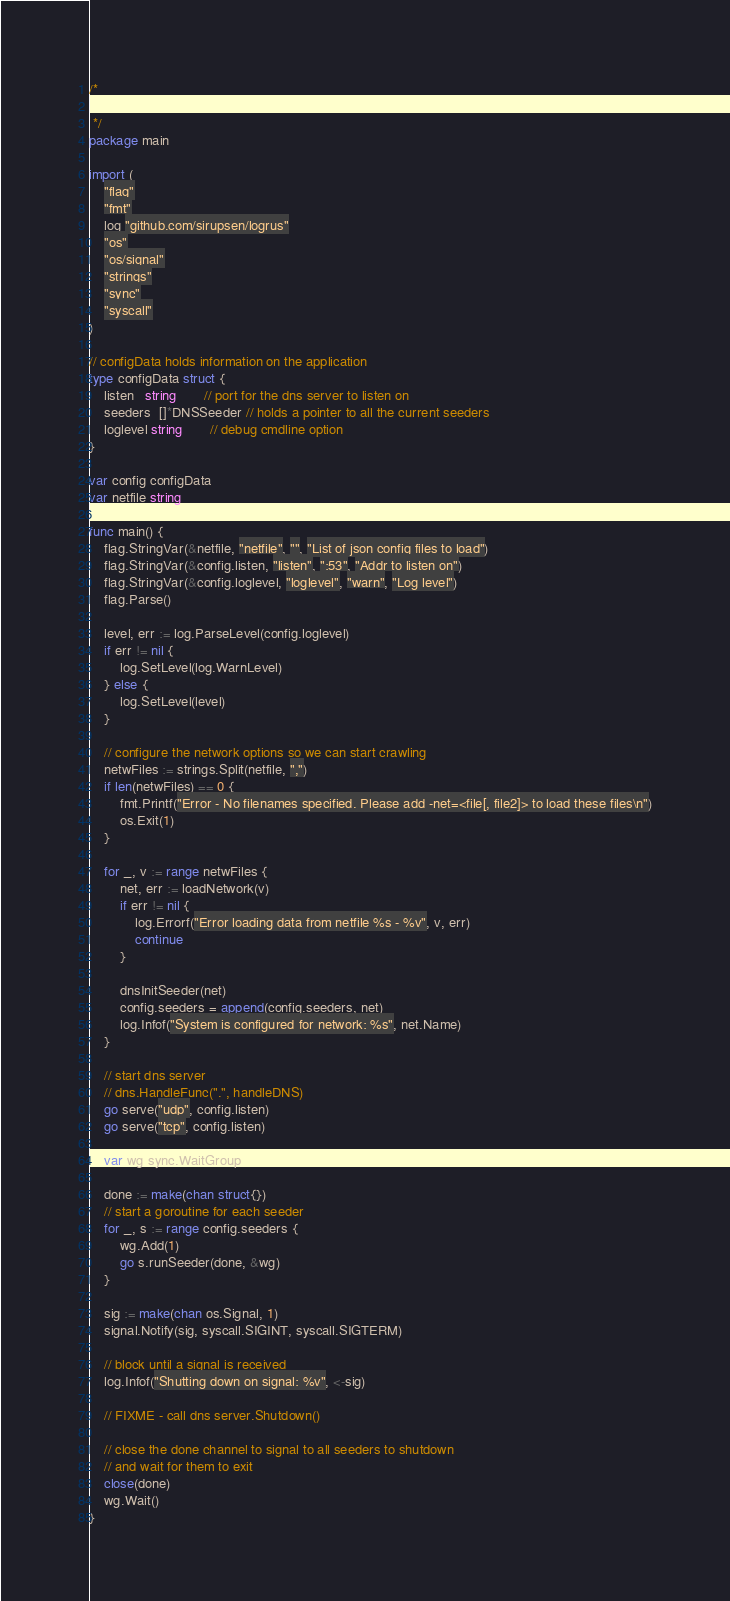Convert code to text. <code><loc_0><loc_0><loc_500><loc_500><_Go_>/*

 */
package main

import (
	"flag"
	"fmt"
	log "github.com/sirupsen/logrus"
	"os"
	"os/signal"
	"strings"
	"sync"
	"syscall"
)

// configData holds information on the application
type configData struct {
	listen   string       // port for the dns server to listen on
	seeders  []*DNSSeeder // holds a pointer to all the current seeders
	loglevel string       // debug cmdline option
}

var config configData
var netfile string

func main() {
	flag.StringVar(&netfile, "netfile", "", "List of json config files to load")
	flag.StringVar(&config.listen, "listen", ":53", "Addr to listen on")
	flag.StringVar(&config.loglevel, "loglevel", "warn", "Log level")
	flag.Parse()

	level, err := log.ParseLevel(config.loglevel)
	if err != nil {
		log.SetLevel(log.WarnLevel)
	} else {
		log.SetLevel(level)
	}

	// configure the network options so we can start crawling
	netwFiles := strings.Split(netfile, ",")
	if len(netwFiles) == 0 {
		fmt.Printf("Error - No filenames specified. Please add -net=<file[, file2]> to load these files\n")
		os.Exit(1)
	}

	for _, v := range netwFiles {
		net, err := loadNetwork(v)
		if err != nil {
			log.Errorf("Error loading data from netfile %s - %v", v, err)
			continue
		}

		dnsInitSeeder(net)
		config.seeders = append(config.seeders, net)
		log.Infof("System is configured for network: %s", net.Name)
	}

	// start dns server
	// dns.HandleFunc(".", handleDNS)
	go serve("udp", config.listen)
	go serve("tcp", config.listen)

	var wg sync.WaitGroup

	done := make(chan struct{})
	// start a goroutine for each seeder
	for _, s := range config.seeders {
		wg.Add(1)
		go s.runSeeder(done, &wg)
	}

	sig := make(chan os.Signal, 1)
	signal.Notify(sig, syscall.SIGINT, syscall.SIGTERM)

	// block until a signal is received
	log.Infof("Shutting down on signal: %v", <-sig)

	// FIXME - call dns server.Shutdown()

	// close the done channel to signal to all seeders to shutdown
	// and wait for them to exit
	close(done)
	wg.Wait()
}
</code> 